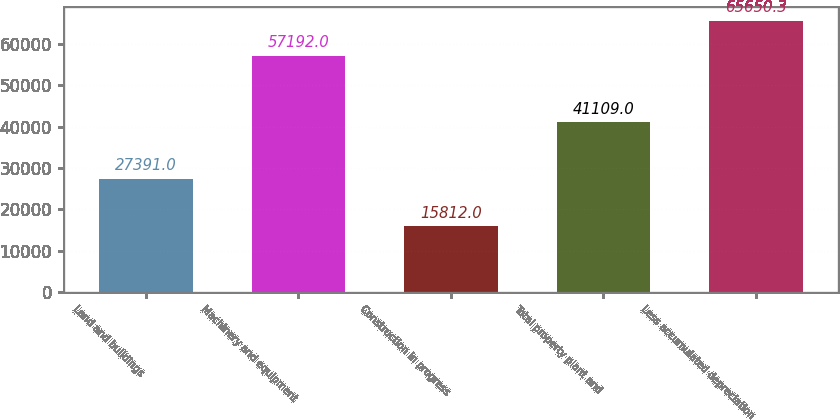<chart> <loc_0><loc_0><loc_500><loc_500><bar_chart><fcel>Land and buildings<fcel>Machinery and equipment<fcel>Construction in progress<fcel>Total property plant and<fcel>Less accumulated depreciation<nl><fcel>27391<fcel>57192<fcel>15812<fcel>41109<fcel>65650.3<nl></chart> 